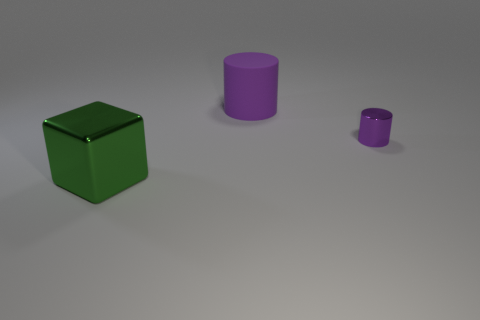What is the size of the other cylinder that is the same color as the shiny cylinder?
Provide a succinct answer. Large. Are there any purple rubber cylinders of the same size as the metallic cylinder?
Keep it short and to the point. No. Are there any big objects that are on the left side of the big thing to the right of the big thing that is in front of the tiny purple cylinder?
Give a very brief answer. Yes. Is the color of the tiny cylinder the same as the metal thing to the left of the small purple thing?
Provide a short and direct response. No. What material is the large thing that is behind the metal object that is to the left of the purple cylinder behind the tiny metallic thing?
Offer a terse response. Rubber. What is the shape of the metal thing that is on the left side of the small purple cylinder?
Your answer should be very brief. Cube. What size is the green block that is the same material as the small cylinder?
Your answer should be compact. Large. How many rubber objects are the same shape as the small purple shiny object?
Keep it short and to the point. 1. Does the big thing behind the large metal block have the same color as the tiny metal object?
Keep it short and to the point. Yes. There is a purple cylinder that is behind the shiny thing that is to the right of the block; how many large metallic cubes are in front of it?
Keep it short and to the point. 1. 